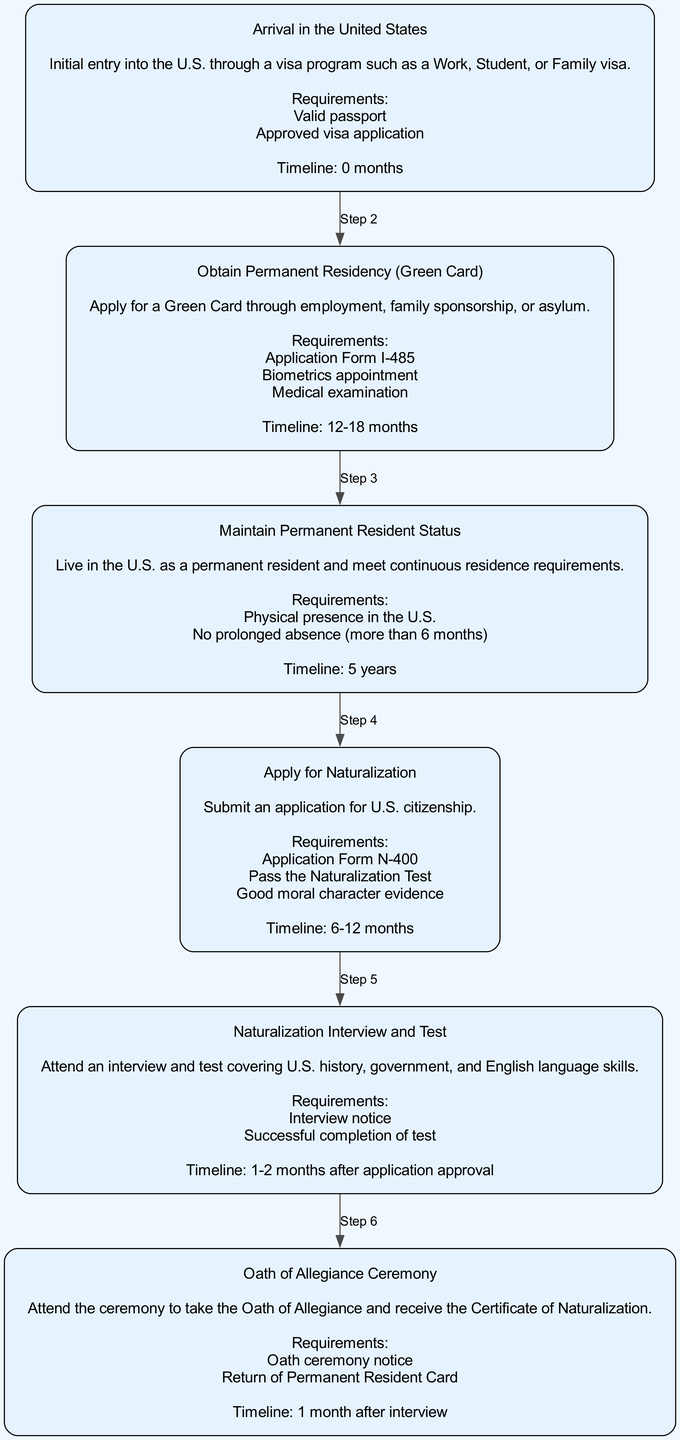What is the first step in the pathway to citizenship? The first step is "Arrival in the United States." This is indicated as the starting node in the diagram, labeled "Step 1."
Answer: Arrival in the United States How many requirements are needed for applying for a Green Card? The Green Card application requires three specific items: Application Form I-485, Biometrics appointment, and Medical examination. This information is provided under "Step 2."
Answer: Three What is the timeline for maintaining permanent resident status? The timeline for maintaining permanent resident status is specified as "5 years" in "Step 3." This indicates how long one must live in the U.S. before applying for citizenship.
Answer: 5 years What must be passed to apply for naturalization? To apply for naturalization, one must pass the Naturalization Test as mentioned in "Step 4." It is included in the requirements necessary for the citizenship application.
Answer: Naturalization Test Which step involves taking the Oath of Allegiance? The step that involves taking the Oath of Allegiance is "Step 6," which is the final step in the pathway to citizenship where the ceremony takes place.
Answer: Step 6 What is the total number of steps in the pathway to citizenship? The total number of steps indicated in the diagram is six, as each step is numbered from 1 to 6 sequentially.
Answer: Six What do you need to bring to the naturalization interview? For the naturalization interview, you need to bring an interview notice and successfully complete the test. This is detailed in "Step 5."
Answer: Interview notice and successful completion of test What is the requirement for maintaining permanent residency regarding absence? The requirement is that there should be no prolonged absence of more than six months, which is a critical requirement outlined in "Step 3."
Answer: More than 6 months What is required to receive the Certificate of Naturalization? To receive the Certificate of Naturalization, one must attend the Oath ceremony and return the Permanent Resident Card, as specified in "Step 6."
Answer: Oath ceremony notice and return of Permanent Resident Card 